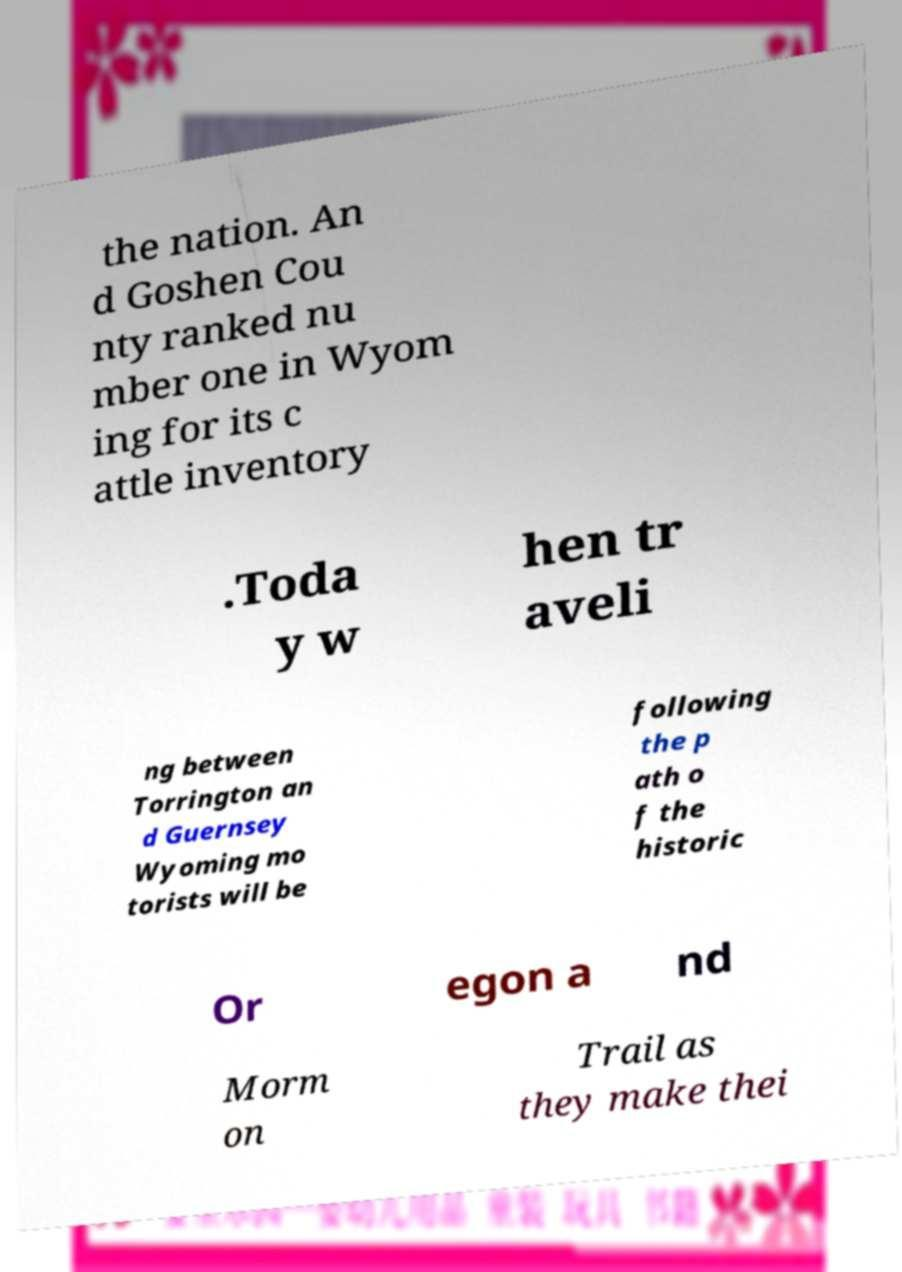What messages or text are displayed in this image? I need them in a readable, typed format. the nation. An d Goshen Cou nty ranked nu mber one in Wyom ing for its c attle inventory .Toda y w hen tr aveli ng between Torrington an d Guernsey Wyoming mo torists will be following the p ath o f the historic Or egon a nd Morm on Trail as they make thei 